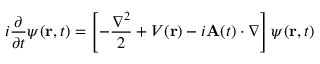Convert formula to latex. <formula><loc_0><loc_0><loc_500><loc_500>i \frac { \partial } { \partial t } \psi ( r , t ) = \left [ - \frac { \nabla ^ { 2 } } { 2 } + V ( r ) - i A ( t ) \cdot \nabla \right ] \psi ( r , t )</formula> 